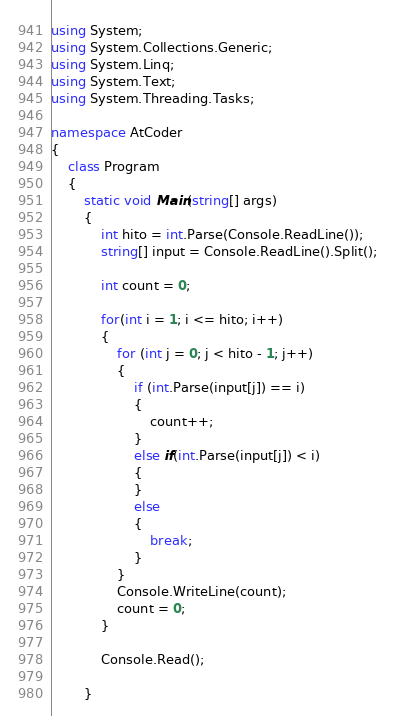<code> <loc_0><loc_0><loc_500><loc_500><_C#_>using System;
using System.Collections.Generic;
using System.Linq;
using System.Text;
using System.Threading.Tasks;

namespace AtCoder
{
    class Program
    {
        static void Main(string[] args)
        {
            int hito = int.Parse(Console.ReadLine());
            string[] input = Console.ReadLine().Split();

            int count = 0;

            for(int i = 1; i <= hito; i++)
            {
                for (int j = 0; j < hito - 1; j++)
                {
                    if (int.Parse(input[j]) == i)
                    {
                        count++;
                    }
                    else if(int.Parse(input[j]) < i)
                    {
                    }
                    else
                    {
                        break;
                    }
                }
                Console.WriteLine(count);
                count = 0;
            }

            Console.Read();

        }</code> 